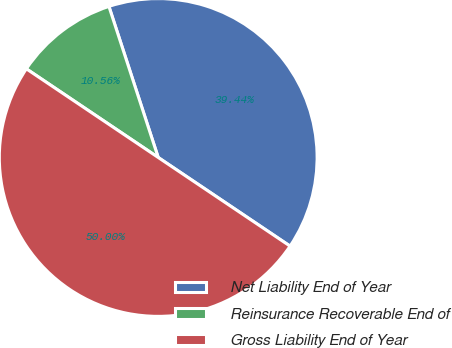<chart> <loc_0><loc_0><loc_500><loc_500><pie_chart><fcel>Net Liability End of Year<fcel>Reinsurance Recoverable End of<fcel>Gross Liability End of Year<nl><fcel>39.44%<fcel>10.56%<fcel>50.0%<nl></chart> 